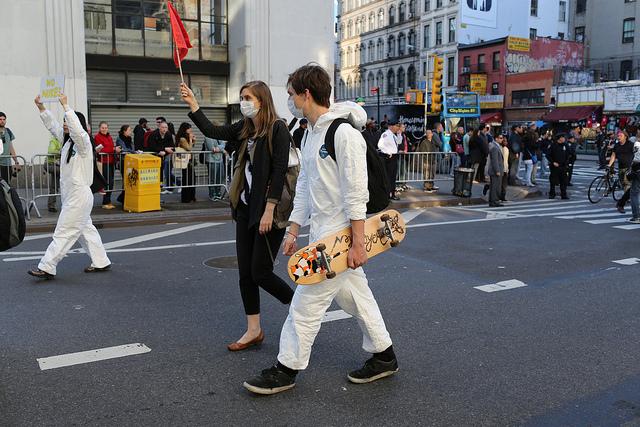Why are the people wearing masks?
Give a very brief answer. Protest. What is in the man's left hand?
Keep it brief. Skateboard. What are the stripes on the road for?
Concise answer only. Passing. How many newsstands are there?
Keep it brief. 1. 